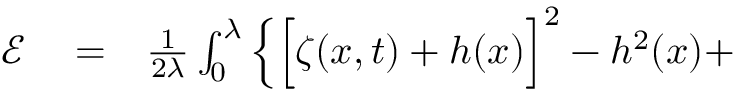Convert formula to latex. <formula><loc_0><loc_0><loc_500><loc_500>\begin{array} { r l r } { \ m a t h s c r { E } } & = } & { \frac { 1 } { 2 \lambda } \int _ { 0 } ^ { \lambda } \Big \{ \Big [ \zeta ( x , t ) + h ( x ) \Big ] ^ { 2 } - h ^ { 2 } ( x ) + } \end{array}</formula> 